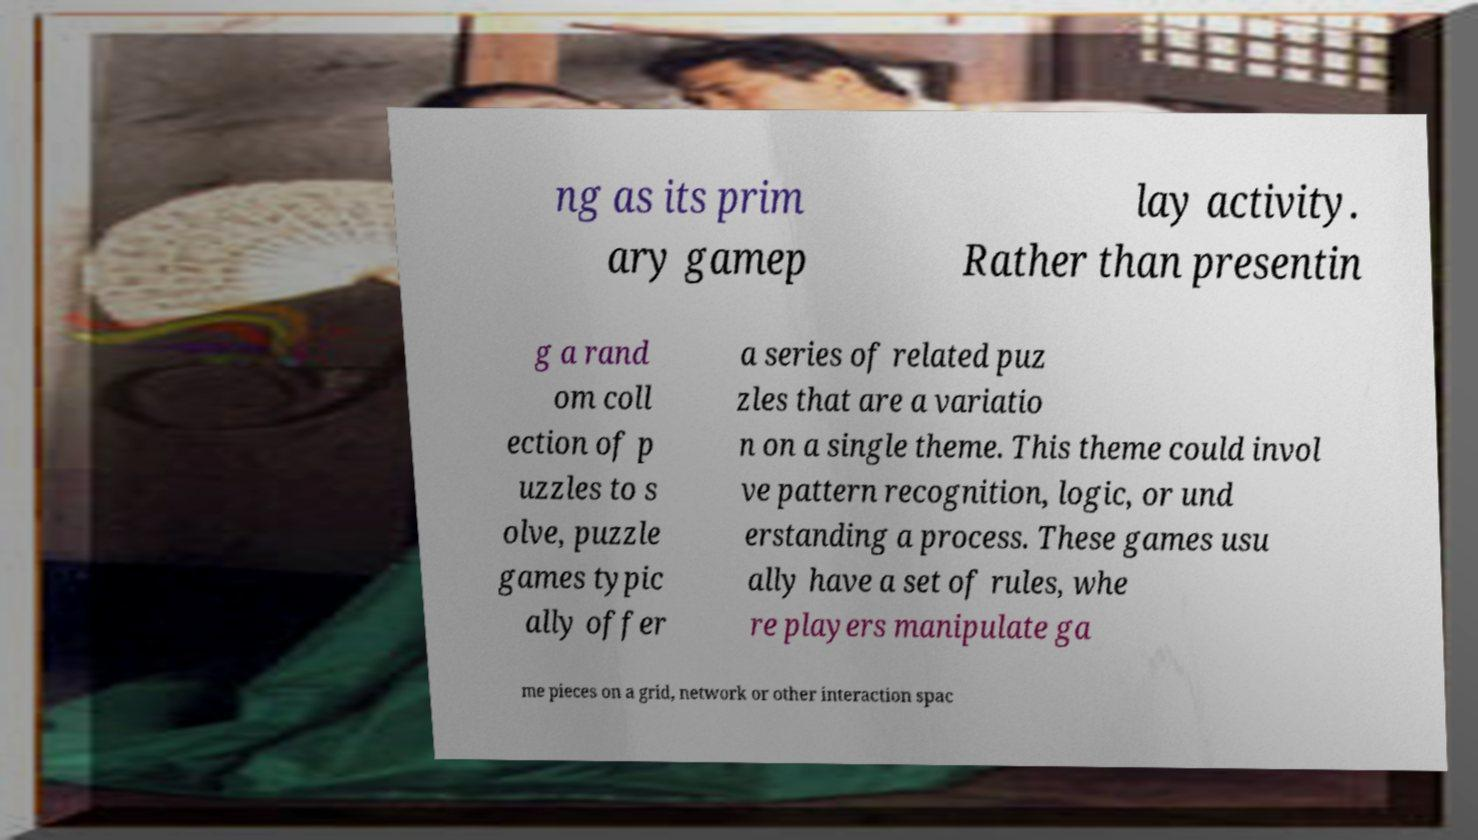Could you extract and type out the text from this image? ng as its prim ary gamep lay activity. Rather than presentin g a rand om coll ection of p uzzles to s olve, puzzle games typic ally offer a series of related puz zles that are a variatio n on a single theme. This theme could invol ve pattern recognition, logic, or und erstanding a process. These games usu ally have a set of rules, whe re players manipulate ga me pieces on a grid, network or other interaction spac 